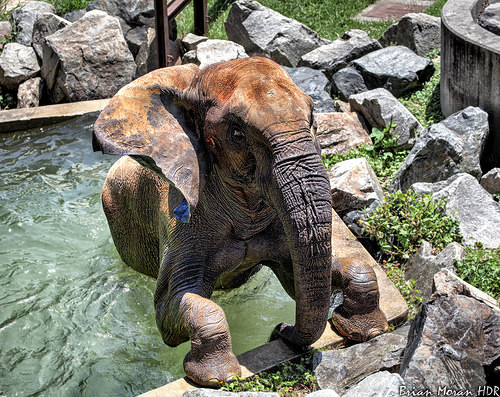<image>
Is there a rock on the elephant? No. The rock is not positioned on the elephant. They may be near each other, but the rock is not supported by or resting on top of the elephant. Where is the elephant in relation to the rock? Is it on the rock? No. The elephant is not positioned on the rock. They may be near each other, but the elephant is not supported by or resting on top of the rock. Where is the elephant in relation to the water? Is it behind the water? No. The elephant is not behind the water. From this viewpoint, the elephant appears to be positioned elsewhere in the scene. Where is the elephant in relation to the water? Is it under the water? No. The elephant is not positioned under the water. The vertical relationship between these objects is different. Where is the elephant in relation to the rocks? Is it above the rocks? No. The elephant is not positioned above the rocks. The vertical arrangement shows a different relationship. 